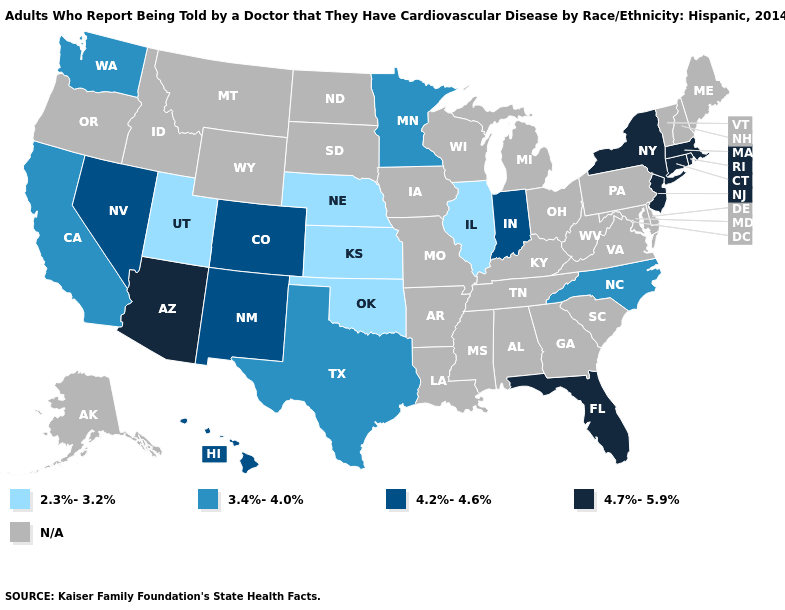Does Utah have the lowest value in the West?
Answer briefly. Yes. Name the states that have a value in the range 4.7%-5.9%?
Answer briefly. Arizona, Connecticut, Florida, Massachusetts, New Jersey, New York, Rhode Island. Which states have the lowest value in the USA?
Answer briefly. Illinois, Kansas, Nebraska, Oklahoma, Utah. What is the lowest value in the USA?
Be succinct. 2.3%-3.2%. Which states have the lowest value in the USA?
Give a very brief answer. Illinois, Kansas, Nebraska, Oklahoma, Utah. Name the states that have a value in the range 3.4%-4.0%?
Write a very short answer. California, Minnesota, North Carolina, Texas, Washington. Name the states that have a value in the range N/A?
Be succinct. Alabama, Alaska, Arkansas, Delaware, Georgia, Idaho, Iowa, Kentucky, Louisiana, Maine, Maryland, Michigan, Mississippi, Missouri, Montana, New Hampshire, North Dakota, Ohio, Oregon, Pennsylvania, South Carolina, South Dakota, Tennessee, Vermont, Virginia, West Virginia, Wisconsin, Wyoming. What is the value of Colorado?
Quick response, please. 4.2%-4.6%. Does Minnesota have the lowest value in the USA?
Concise answer only. No. Which states hav the highest value in the Northeast?
Give a very brief answer. Connecticut, Massachusetts, New Jersey, New York, Rhode Island. 